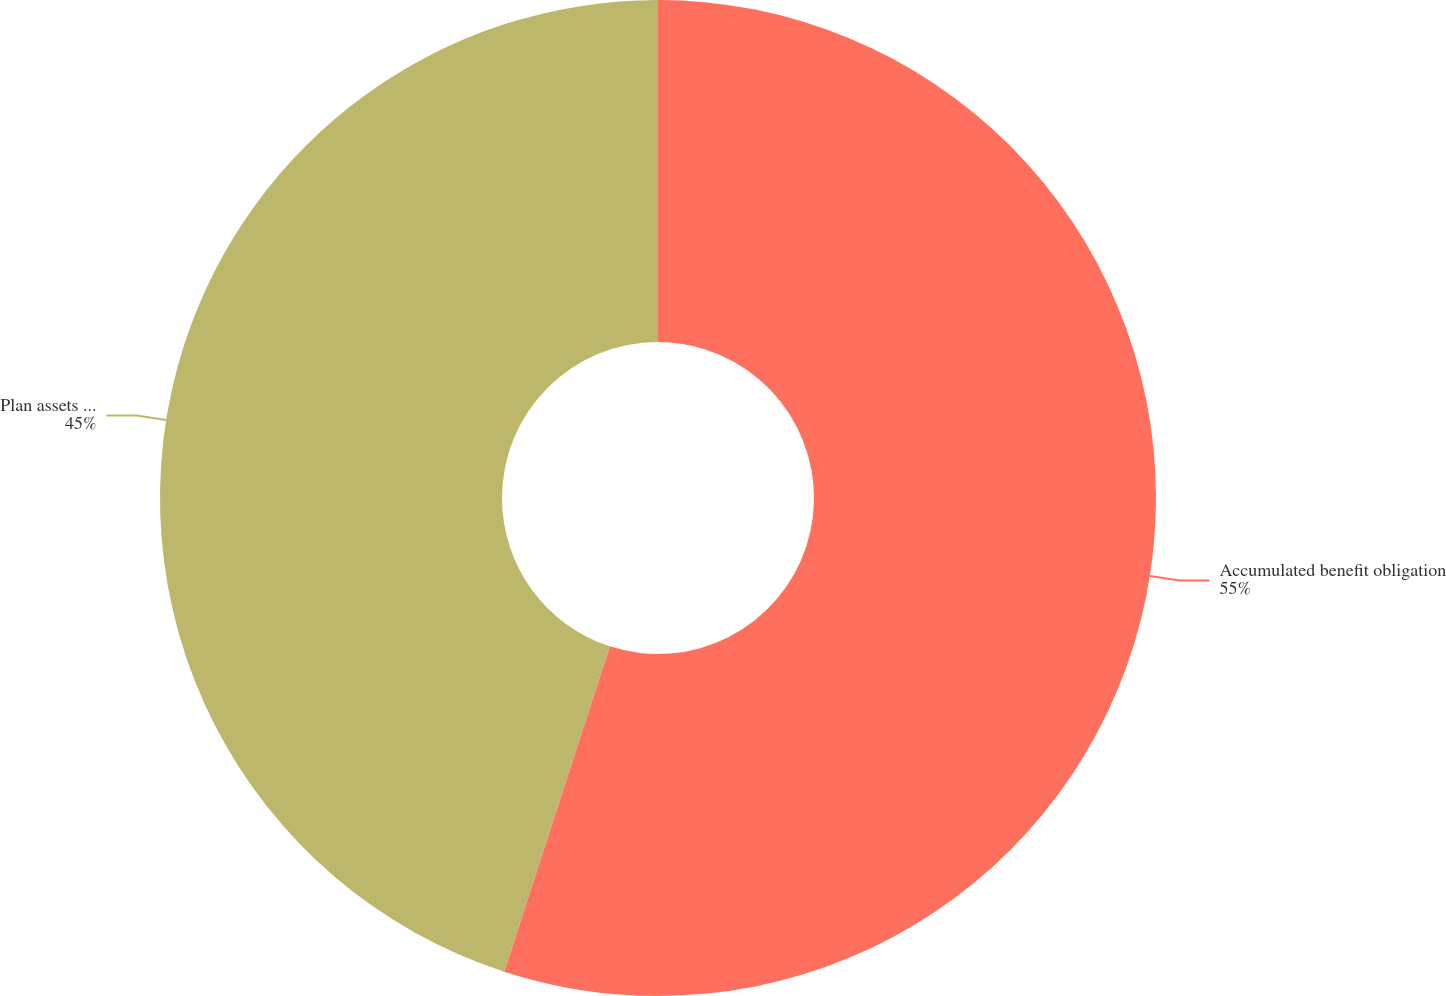Convert chart. <chart><loc_0><loc_0><loc_500><loc_500><pie_chart><fcel>Accumulated benefit obligation<fcel>Plan assets at fair market<nl><fcel>55.0%<fcel>45.0%<nl></chart> 